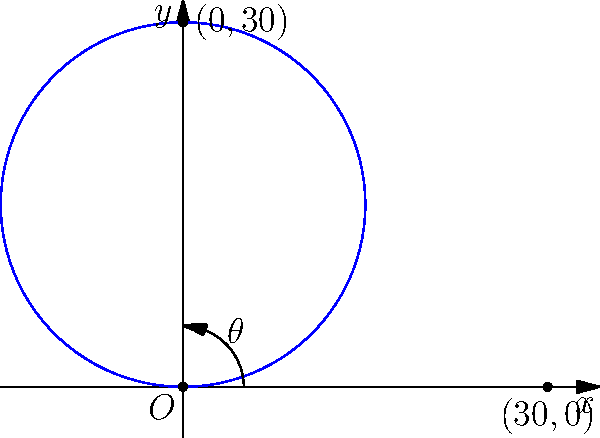In a crucial match against Sweden, you're tasked with taking a free kick. Believing in the lucky number 30, you decide to model the trajectory of your "perfect" kick using the polar equation $r = 30\sin(\theta)$, where $r$ is in meters. If the kick reaches its maximum height at $\theta = \frac{\pi}{2}$, what are the Cartesian coordinates of this highest point? Let's approach this step-by-step:

1) The polar equation given is $r = 30\sin(\theta)$.

2) We're told that the kick reaches its maximum height at $\theta = \frac{\pi}{2}$.

3) To convert from polar to Cartesian coordinates, we use these formulas:
   $x = r\cos(\theta)$
   $y = r\sin(\theta)$

4) Let's calculate $r$ when $\theta = \frac{\pi}{2}$:
   $r = 30\sin(\frac{\pi}{2}) = 30 \cdot 1 = 30$

5) Now, let's calculate $x$ and $y$:
   $x = 30\cos(\frac{\pi}{2}) = 30 \cdot 0 = 0$
   $y = 30\sin(\frac{\pi}{2}) = 30 \cdot 1 = 30$

6) Therefore, the Cartesian coordinates of the highest point are (0, 30).

This means your "lucky" kick reaches a maximum height of 30 meters directly above the point where it was kicked, aligning perfectly with your lucky number!
Answer: (0, 30) 